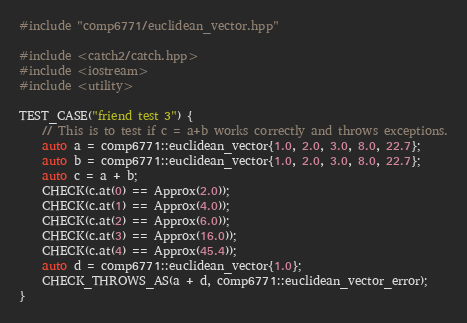<code> <loc_0><loc_0><loc_500><loc_500><_C++_>#include "comp6771/euclidean_vector.hpp"

#include <catch2/catch.hpp>
#include <iostream>
#include <utility>

TEST_CASE("friend test 3") {
    // This is to test if c = a+b works correctly and throws exceptions.
	auto a = comp6771::euclidean_vector{1.0, 2.0, 3.0, 8.0, 22.7};
	auto b = comp6771::euclidean_vector{1.0, 2.0, 3.0, 8.0, 22.7};
	auto c = a + b;
	CHECK(c.at(0) == Approx(2.0));
	CHECK(c.at(1) == Approx(4.0));
	CHECK(c.at(2) == Approx(6.0));
	CHECK(c.at(3) == Approx(16.0));
	CHECK(c.at(4) == Approx(45.4));
	auto d = comp6771::euclidean_vector{1.0};
	CHECK_THROWS_AS(a + d, comp6771::euclidean_vector_error);
}</code> 